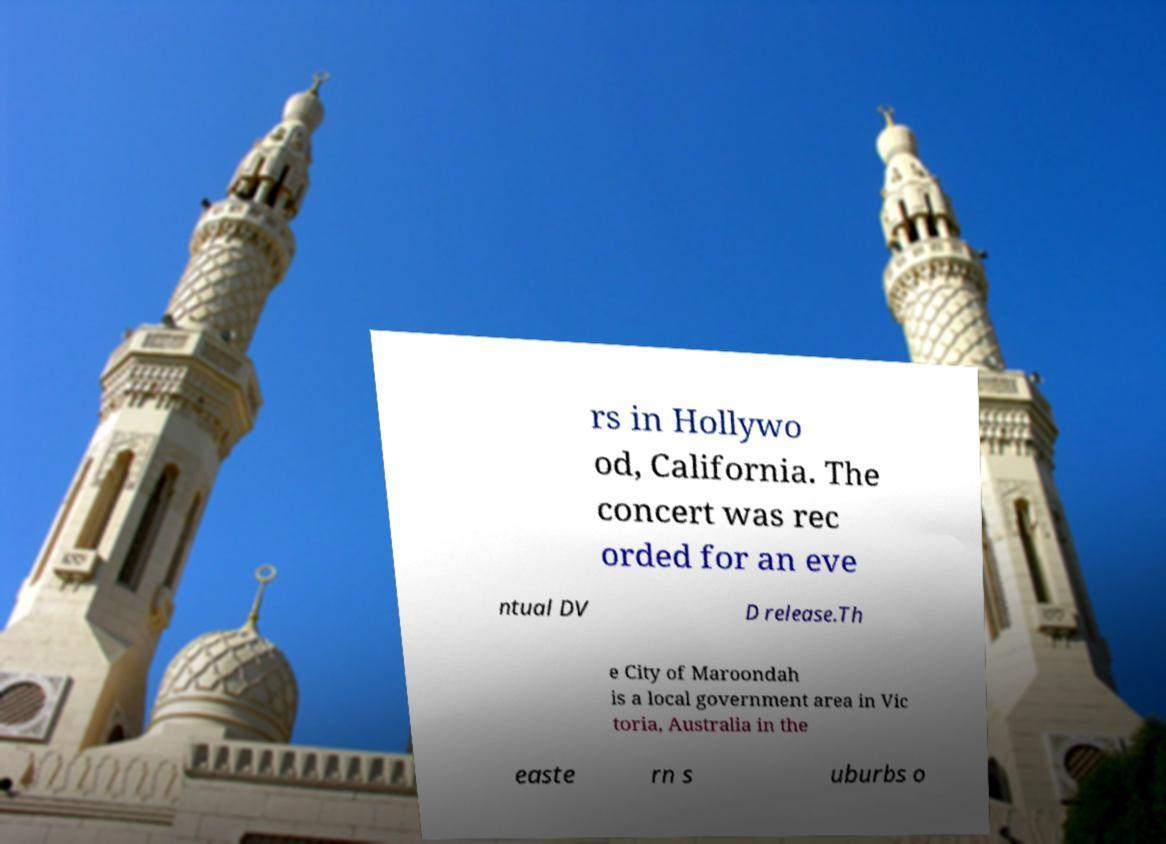Can you read and provide the text displayed in the image?This photo seems to have some interesting text. Can you extract and type it out for me? rs in Hollywo od, California. The concert was rec orded for an eve ntual DV D release.Th e City of Maroondah is a local government area in Vic toria, Australia in the easte rn s uburbs o 